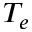Convert formula to latex. <formula><loc_0><loc_0><loc_500><loc_500>T _ { e }</formula> 